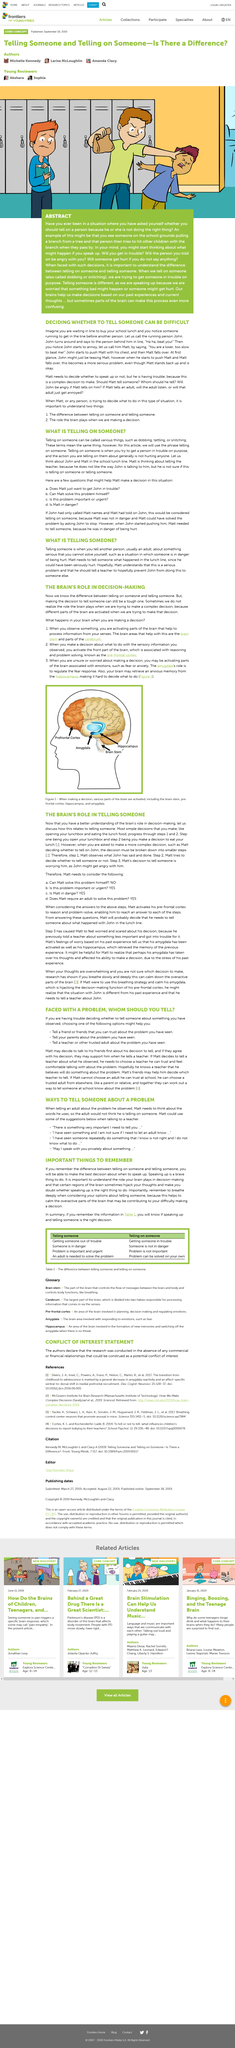List a handful of essential elements in this visual. It is likely that Matt will decide to inform someone about the incident involving John. Making a decision activates the brain stem, prefrontal cortex, amygdala, and hippocampus in the brain. The two persons in the example are Matt and John. Telling someone and telling on someone are two distinct actions that require careful consideration of the potential consequences. When one chooses to tell someone, they are imparting information or seeking assistance in a manner that emphasizes their commitment to shared understanding and cooperation. On the other hand, when one chooses to tell on someone, they are making a disclosure with the intention of betraying trust and possibly causing harm or distress. In general, the stakes are higher when one chooses to tell someone, as the potential for danger or the importance of the issue at hand may be more significant. The differences between telling someone and telling on someone can be found in table 1, which is located in... 